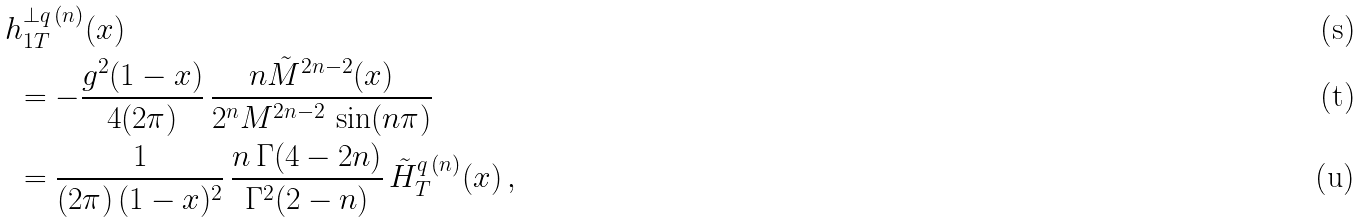<formula> <loc_0><loc_0><loc_500><loc_500>& h _ { 1 T } ^ { \bot q \, ( n ) } ( x ) \\ & \ = - \frac { g ^ { 2 } ( 1 - x ) } { 4 ( 2 \pi ) } \, \frac { n \tilde { M } ^ { 2 n - 2 } ( x ) } { 2 ^ { n } M ^ { 2 n - 2 } \, \sin ( n \pi ) } \\ & \ = \frac { 1 } { ( 2 \pi ) \, ( 1 - x ) ^ { 2 } } \, \frac { n \, \Gamma ( 4 - 2 n ) } { \Gamma ^ { 2 } ( 2 - n ) } \, \tilde { H } _ { T } ^ { q \, ( n ) } ( x ) \, ,</formula> 